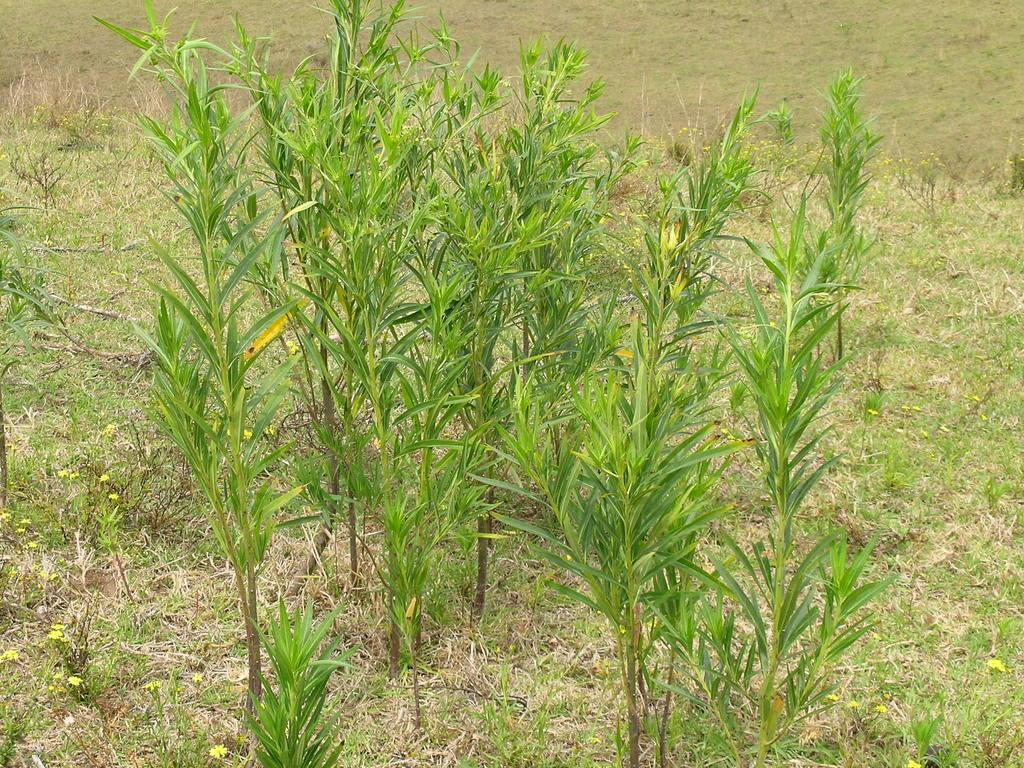What type of vegetation is visible in the front of the image? There are plants in the front of the image. What type of ground cover is present at the bottom of the image? There is grass at the bottom of the image. What type of flowers can be seen at the bottom of the image? There are flowers at the bottom of the image. What type of authority figure can be seen in the image? There is no authority figure present in the image; it features plants, grass, and flowers. How many ducks are visible in the image? There are no ducks present in the image. 